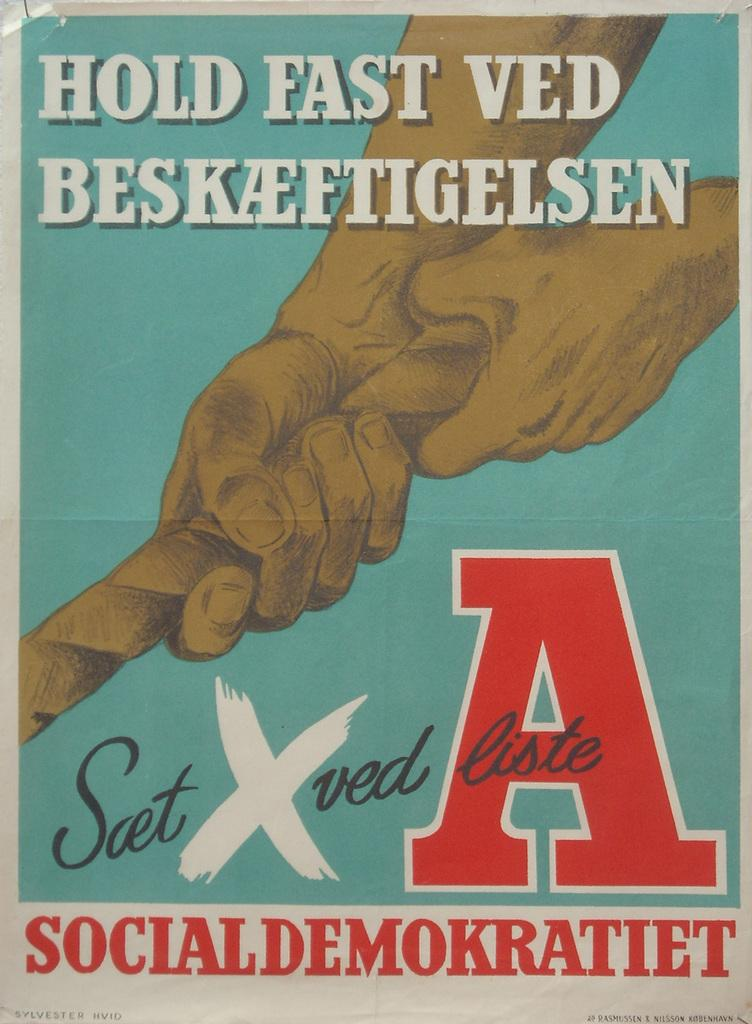<image>
Summarize the visual content of the image. Poster showing a hand holding a rope with the letter A. 